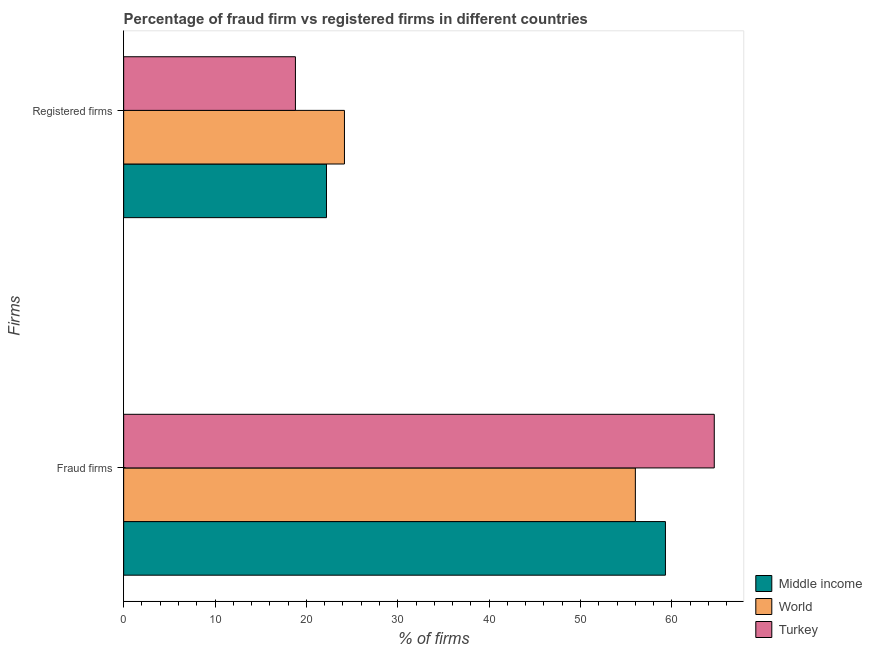How many different coloured bars are there?
Provide a succinct answer. 3. How many groups of bars are there?
Offer a terse response. 2. Are the number of bars per tick equal to the number of legend labels?
Offer a terse response. Yes. How many bars are there on the 1st tick from the top?
Make the answer very short. 3. How many bars are there on the 1st tick from the bottom?
Give a very brief answer. 3. What is the label of the 1st group of bars from the top?
Your response must be concise. Registered firms. What is the percentage of registered firms in Turkey?
Offer a terse response. 18.8. Across all countries, what is the maximum percentage of registered firms?
Ensure brevity in your answer.  24.17. Across all countries, what is the minimum percentage of registered firms?
Offer a very short reply. 18.8. In which country was the percentage of registered firms maximum?
Offer a terse response. World. In which country was the percentage of registered firms minimum?
Your answer should be compact. Turkey. What is the total percentage of fraud firms in the graph?
Provide a succinct answer. 179.94. What is the difference between the percentage of registered firms in World and that in Middle income?
Make the answer very short. 1.97. What is the difference between the percentage of registered firms in Middle income and the percentage of fraud firms in Turkey?
Ensure brevity in your answer.  -42.44. What is the average percentage of registered firms per country?
Your response must be concise. 21.72. What is the difference between the percentage of fraud firms and percentage of registered firms in World?
Give a very brief answer. 31.84. What is the ratio of the percentage of fraud firms in World to that in Middle income?
Offer a very short reply. 0.94. Is the percentage of fraud firms in Middle income less than that in World?
Keep it short and to the point. No. What does the 3rd bar from the top in Registered firms represents?
Provide a short and direct response. Middle income. How many bars are there?
Make the answer very short. 6. Are all the bars in the graph horizontal?
Make the answer very short. Yes. How many countries are there in the graph?
Make the answer very short. 3. What is the difference between two consecutive major ticks on the X-axis?
Provide a succinct answer. 10. Does the graph contain grids?
Provide a short and direct response. No. How many legend labels are there?
Keep it short and to the point. 3. What is the title of the graph?
Ensure brevity in your answer.  Percentage of fraud firm vs registered firms in different countries. Does "Iran" appear as one of the legend labels in the graph?
Your response must be concise. No. What is the label or title of the X-axis?
Your answer should be very brief. % of firms. What is the label or title of the Y-axis?
Provide a short and direct response. Firms. What is the % of firms of Middle income in Fraud firms?
Provide a short and direct response. 59.3. What is the % of firms of World in Fraud firms?
Provide a short and direct response. 56.01. What is the % of firms in Turkey in Fraud firms?
Give a very brief answer. 64.64. What is the % of firms of World in Registered firms?
Offer a very short reply. 24.17. Across all Firms, what is the maximum % of firms of Middle income?
Give a very brief answer. 59.3. Across all Firms, what is the maximum % of firms of World?
Provide a succinct answer. 56.01. Across all Firms, what is the maximum % of firms in Turkey?
Ensure brevity in your answer.  64.64. Across all Firms, what is the minimum % of firms of Middle income?
Your answer should be very brief. 22.2. Across all Firms, what is the minimum % of firms in World?
Provide a short and direct response. 24.17. What is the total % of firms in Middle income in the graph?
Make the answer very short. 81.5. What is the total % of firms in World in the graph?
Ensure brevity in your answer.  80.17. What is the total % of firms in Turkey in the graph?
Provide a short and direct response. 83.44. What is the difference between the % of firms in Middle income in Fraud firms and that in Registered firms?
Make the answer very short. 37.1. What is the difference between the % of firms of World in Fraud firms and that in Registered firms?
Your response must be concise. 31.84. What is the difference between the % of firms in Turkey in Fraud firms and that in Registered firms?
Provide a succinct answer. 45.84. What is the difference between the % of firms of Middle income in Fraud firms and the % of firms of World in Registered firms?
Provide a succinct answer. 35.13. What is the difference between the % of firms of Middle income in Fraud firms and the % of firms of Turkey in Registered firms?
Your answer should be very brief. 40.5. What is the difference between the % of firms in World in Fraud firms and the % of firms in Turkey in Registered firms?
Provide a succinct answer. 37.2. What is the average % of firms in Middle income per Firms?
Make the answer very short. 40.75. What is the average % of firms in World per Firms?
Your response must be concise. 40.09. What is the average % of firms of Turkey per Firms?
Provide a succinct answer. 41.72. What is the difference between the % of firms of Middle income and % of firms of World in Fraud firms?
Provide a short and direct response. 3.29. What is the difference between the % of firms of Middle income and % of firms of Turkey in Fraud firms?
Provide a short and direct response. -5.34. What is the difference between the % of firms in World and % of firms in Turkey in Fraud firms?
Provide a succinct answer. -8.63. What is the difference between the % of firms in Middle income and % of firms in World in Registered firms?
Offer a terse response. -1.97. What is the difference between the % of firms in World and % of firms in Turkey in Registered firms?
Ensure brevity in your answer.  5.37. What is the ratio of the % of firms in Middle income in Fraud firms to that in Registered firms?
Give a very brief answer. 2.67. What is the ratio of the % of firms in World in Fraud firms to that in Registered firms?
Your answer should be compact. 2.32. What is the ratio of the % of firms in Turkey in Fraud firms to that in Registered firms?
Keep it short and to the point. 3.44. What is the difference between the highest and the second highest % of firms of Middle income?
Your response must be concise. 37.1. What is the difference between the highest and the second highest % of firms in World?
Your response must be concise. 31.84. What is the difference between the highest and the second highest % of firms of Turkey?
Offer a very short reply. 45.84. What is the difference between the highest and the lowest % of firms in Middle income?
Make the answer very short. 37.1. What is the difference between the highest and the lowest % of firms of World?
Make the answer very short. 31.84. What is the difference between the highest and the lowest % of firms in Turkey?
Make the answer very short. 45.84. 